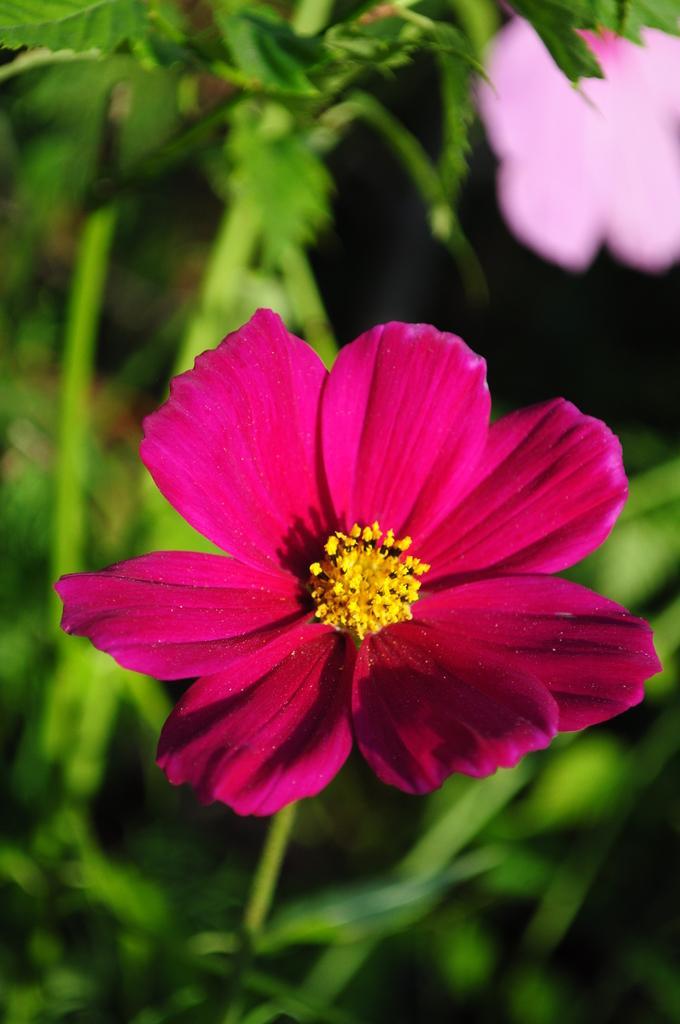Describe this image in one or two sentences. In this image we can see a flower, leaves, and stems. At the top right corner of the image we can see a pink color object. 